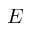<formula> <loc_0><loc_0><loc_500><loc_500>E</formula> 